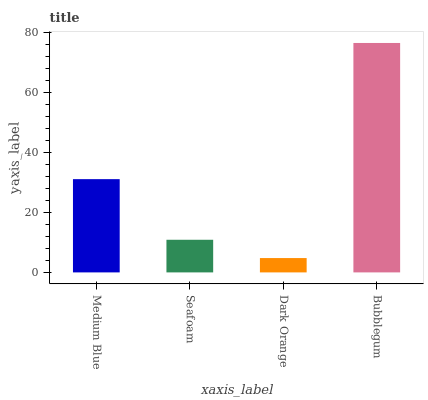Is Dark Orange the minimum?
Answer yes or no. Yes. Is Bubblegum the maximum?
Answer yes or no. Yes. Is Seafoam the minimum?
Answer yes or no. No. Is Seafoam the maximum?
Answer yes or no. No. Is Medium Blue greater than Seafoam?
Answer yes or no. Yes. Is Seafoam less than Medium Blue?
Answer yes or no. Yes. Is Seafoam greater than Medium Blue?
Answer yes or no. No. Is Medium Blue less than Seafoam?
Answer yes or no. No. Is Medium Blue the high median?
Answer yes or no. Yes. Is Seafoam the low median?
Answer yes or no. Yes. Is Seafoam the high median?
Answer yes or no. No. Is Dark Orange the low median?
Answer yes or no. No. 